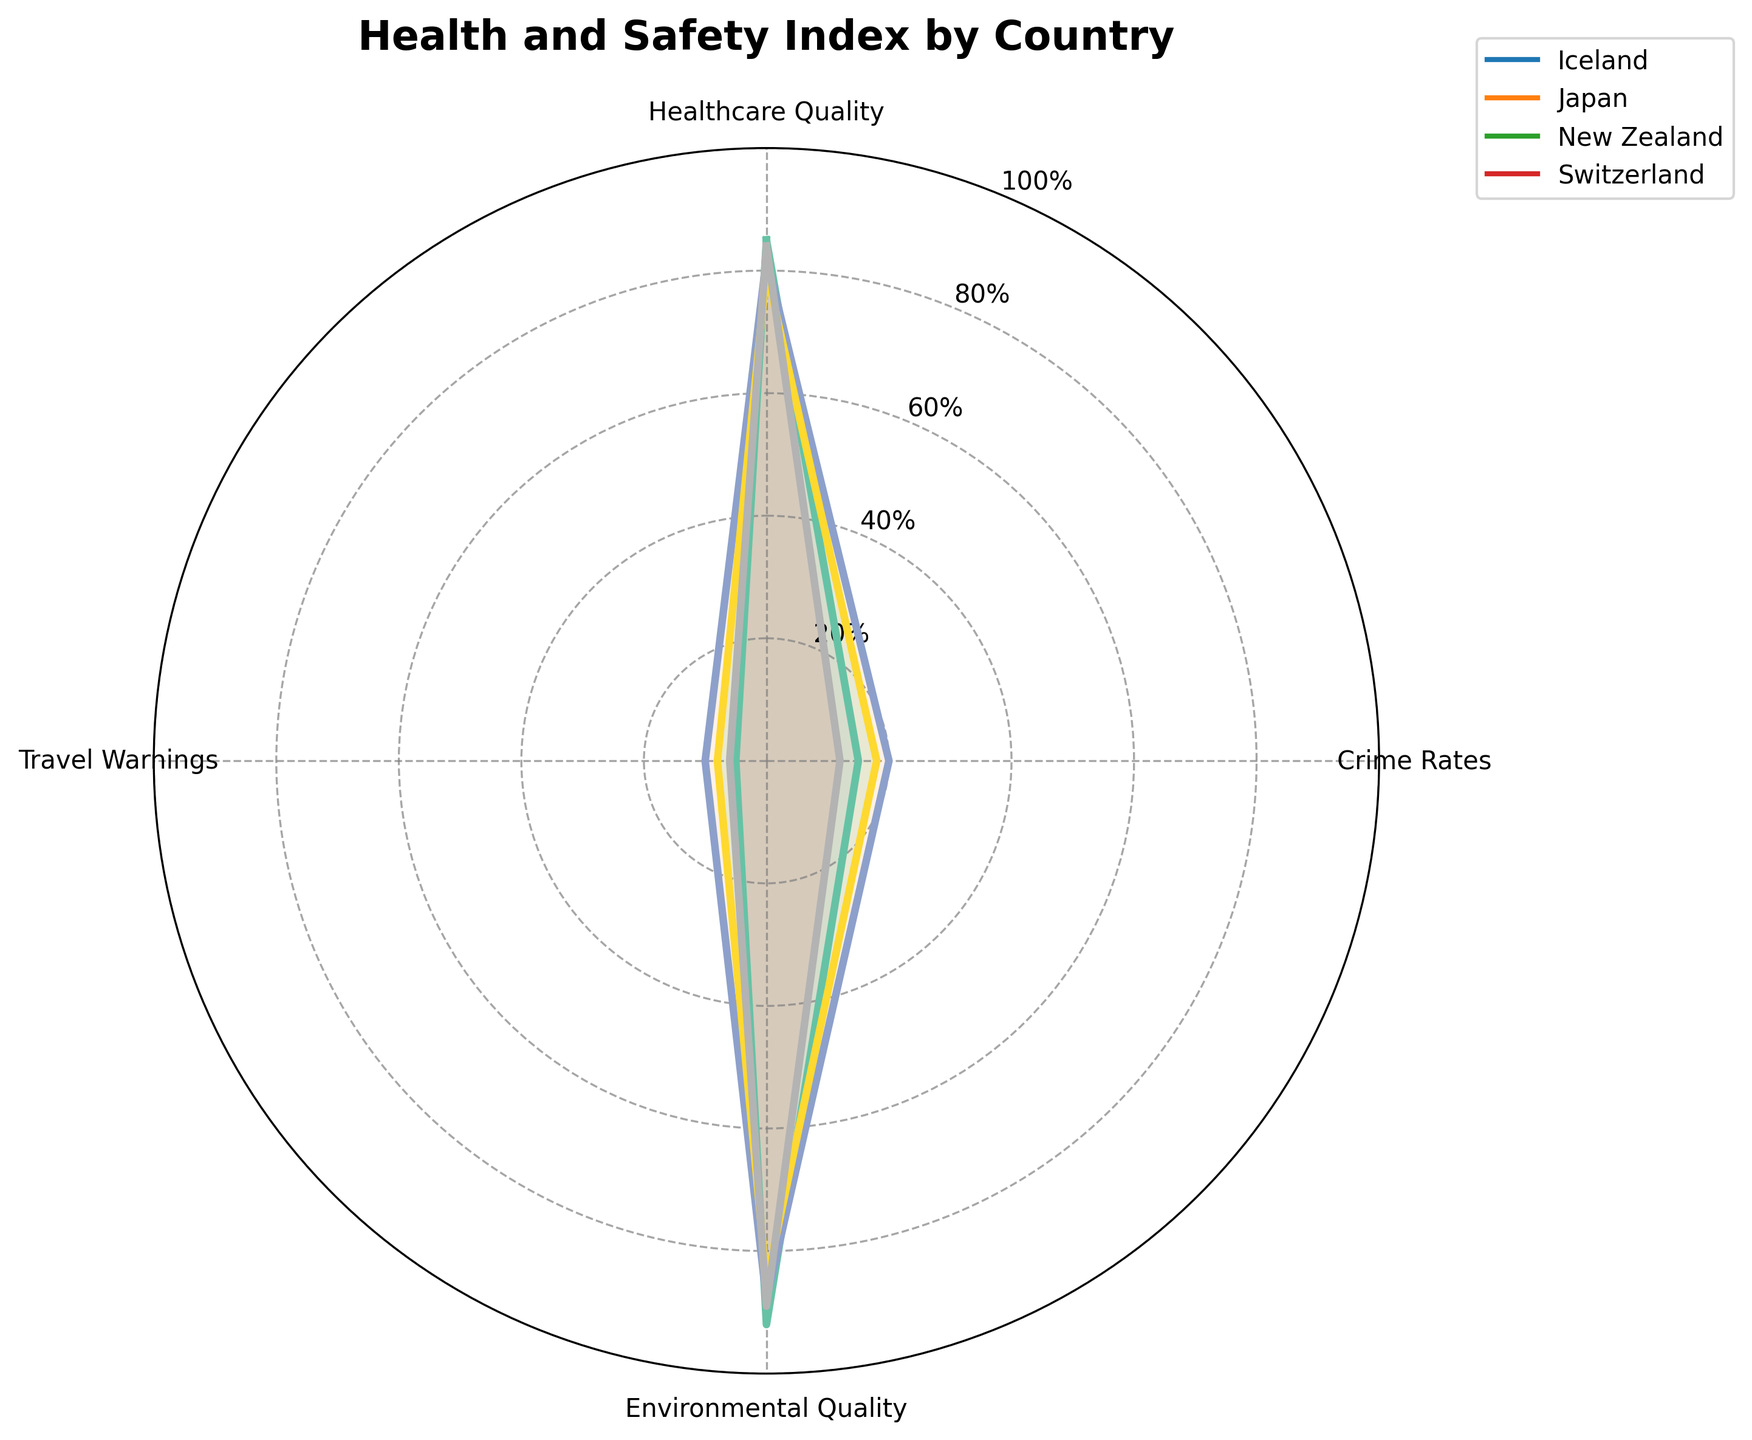what is the highest crime rate among the countries? From the radar chart, we can observe the lengths of the segments corresponding to Crime Rates for each country. The highest value among these is 20, which is for Japan.
Answer: 20 Which country has the lowest travel warning index? By looking at the segments for Travel Warnings, we see that Iceland has a value of 5, which is the lowest among the four countries.
Answer: Iceland How do Iceland and Japan compare in terms of environmental quality? We can compare the lengths of the segments corresponding to Environmental Quality for both Iceland and Japan. Iceland has a value of 92, and Japan has a value of 88. Iceland's environmental quality is higher.
Answer: Iceland Which two countries have the closest crime rates? By examining the lengths of the segments for Crime Rates, we see that New Zealand and Japan have values of 18 and 20, respectively. The difference between them is 2, which is the smallest difference among all pairs.
Answer: New Zealand and Japan What is the average healthcare quality index across all countries? First, sum up the healthcare quality indices: 85 (Iceland) + 82 (Japan) + 80 (New Zealand) + 84 (Switzerland) = 331. Then divide by the number of countries, which is 4. The average is 331 / 4 = 82.75.
Answer: 82.75 Which country has the highest overall health and safety index based on the four categories? Compute the sum of values for each country. Iceland: 85 + 15 + 92 + 5 = 197, Japan: 82 + 20 + 88 + 10 = 200, New Zealand: 80 + 18 + 85 + 8 = 191, Switzerland: 84 + 12 + 89 + 6 = 191. Japan has the highest total index.
Answer: Japan Are there any countries where the crime rate is less than 15? By examining the Crime Rates segments, we see that Switzerland has a value of 12, which is less than 15.
Answer: Switzerland Which country has the highest travel warning index? By comparing the lengths of the segments for Travel Warnings, Japan has the highest value, which is 10.
Answer: Japan How do the healthcare quality indices compare between Switzerland and Iceland? The radar chart shows that Switzerland has a healthcare quality index of 84, while Iceland has an index of 85. Iceland's index is slightly higher by 1 point.
Answer: Iceland What is the range of environmental quality indices across all countries? The highest environmental quality index is 92 (Iceland), and the lowest is 85 (New Zealand). The range is 92 - 85 = 7.
Answer: 7 